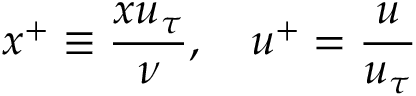<formula> <loc_0><loc_0><loc_500><loc_500>x ^ { + } \equiv \frac { x u _ { \tau } } { \nu } , \quad u ^ { + } = \frac { u } { u _ { \tau } }</formula> 